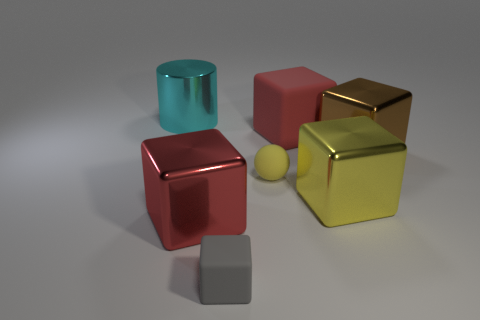Subtract all gray matte blocks. How many blocks are left? 4 Subtract all cyan balls. How many red cubes are left? 2 Add 3 small blue metallic cylinders. How many objects exist? 10 Subtract all red blocks. How many blocks are left? 3 Subtract all blue cubes. Subtract all brown spheres. How many cubes are left? 5 Subtract all small red matte blocks. Subtract all big cylinders. How many objects are left? 6 Add 6 small blocks. How many small blocks are left? 7 Add 1 metallic objects. How many metallic objects exist? 5 Subtract 0 purple cylinders. How many objects are left? 7 Subtract all cubes. How many objects are left? 2 